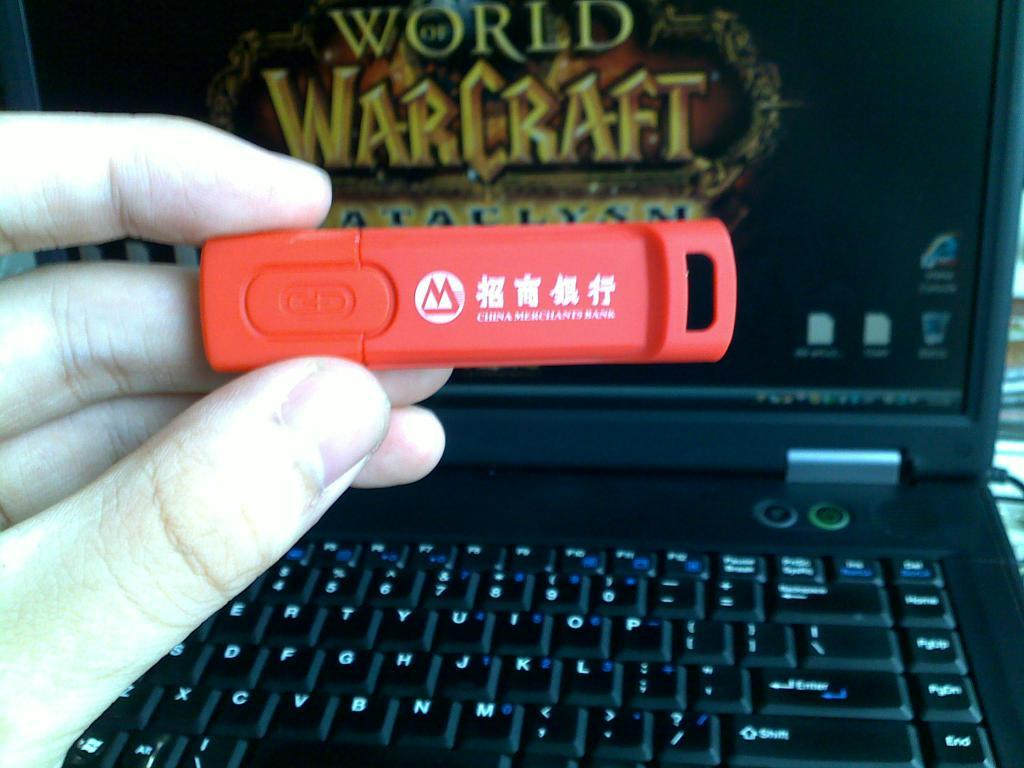<image>
Give a short and clear explanation of the subsequent image. A hand holds up a usb in front of a laptop with World of Warcraft on the screen. 